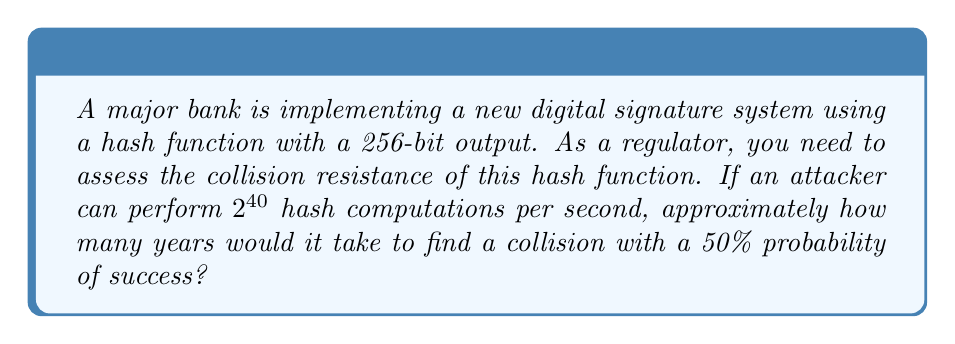Help me with this question. To solve this problem, we'll follow these steps:

1. Understand the birthday attack:
   The birthday attack is the most efficient method to find collisions in hash functions. For a hash function with an n-bit output, the probability of finding a collision after q attempts is approximately:

   $$ P(q) \approx 1 - e^{-q^2 / (2^{n+1})} $$

2. Set up the equation for 50% probability:
   We want $P(q) = 0.5$, so:

   $$ 0.5 = 1 - e^{-q^2 / (2^{257})} $$

3. Solve for q:
   $$ e^{-q^2 / (2^{257})} = 0.5 $$
   $$ -q^2 / (2^{257}) = \ln(0.5) $$
   $$ q^2 = -2^{257} \cdot \ln(0.5) $$
   $$ q = \sqrt{-2^{257} \cdot \ln(0.5)} \approx 2^{128.5} $$

4. Calculate the time required:
   Number of computations: $2^{128.5}$
   Computations per second: $2^{40}$
   Time in seconds: $2^{128.5} / 2^{40} = 2^{88.5}$

5. Convert seconds to years:
   Seconds in a year: $365.25 \cdot 24 \cdot 60 \cdot 60 = 31,557,600$
   Years: $2^{88.5} / 31,557,600 \approx 2^{68.5}$
Answer: $2^{68.5}$ years 